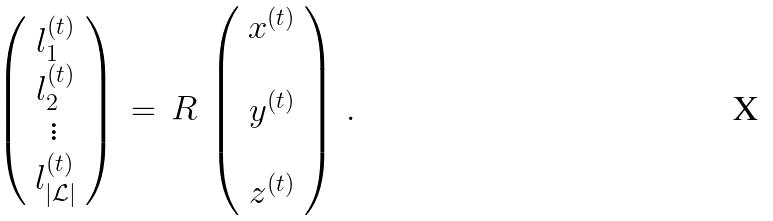Convert formula to latex. <formula><loc_0><loc_0><loc_500><loc_500>\left ( \begin{array} { c } l _ { 1 } ^ { ( t ) } \\ l _ { 2 } ^ { ( t ) } \\ \vdots \\ l _ { | \mathcal { L } | } ^ { ( t ) } \end{array} \right ) \, = \, R \, \left ( \begin{array} { c } x ^ { ( t ) } \\ \\ y ^ { ( t ) } \\ \\ z ^ { ( t ) } \end{array} \right ) \, .</formula> 